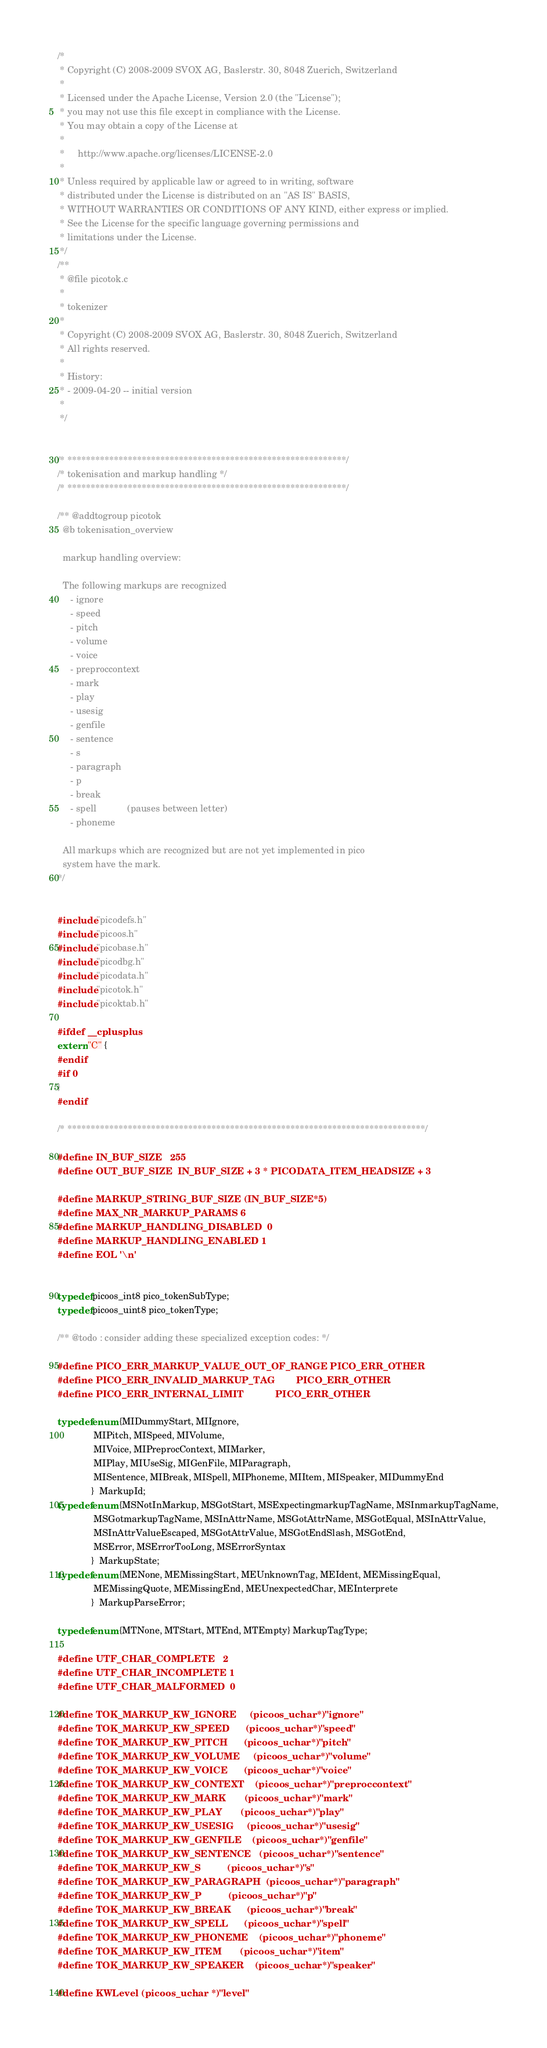<code> <loc_0><loc_0><loc_500><loc_500><_C_>/*
 * Copyright (C) 2008-2009 SVOX AG, Baslerstr. 30, 8048 Zuerich, Switzerland
 *
 * Licensed under the Apache License, Version 2.0 (the "License");
 * you may not use this file except in compliance with the License.
 * You may obtain a copy of the License at
 *
 *     http://www.apache.org/licenses/LICENSE-2.0
 *
 * Unless required by applicable law or agreed to in writing, software
 * distributed under the License is distributed on an "AS IS" BASIS,
 * WITHOUT WARRANTIES OR CONDITIONS OF ANY KIND, either express or implied.
 * See the License for the specific language governing permissions and
 * limitations under the License.
 */
/**
 * @file picotok.c
 *
 * tokenizer
 *
 * Copyright (C) 2008-2009 SVOX AG, Baslerstr. 30, 8048 Zuerich, Switzerland
 * All rights reserved.
 *
 * History:
 * - 2009-04-20 -- initial version
 *
 */


/* ************************************************************/
/* tokenisation and markup handling */
/* ************************************************************/

/** @addtogroup picotok
  @b tokenisation_overview

  markup handling overview:

  The following markups are recognized
     - ignore
     - speed
     - pitch
     - volume
     - voice
     - preproccontext
     - mark
     - play
     - usesig
     - genfile
     - sentence
     - s
     - paragraph
     - p
     - break
     - spell            (pauses between letter)
     - phoneme

  All markups which are recognized but are not yet implemented in pico
  system have the mark.
*/


#include "picodefs.h"
#include "picoos.h"
#include "picobase.h"
#include "picodbg.h"
#include "picodata.h"
#include "picotok.h"
#include "picoktab.h"

#ifdef __cplusplus
extern "C" {
#endif
#if 0
}
#endif

/* *****************************************************************************/

#define IN_BUF_SIZE   255
#define OUT_BUF_SIZE  IN_BUF_SIZE + 3 * PICODATA_ITEM_HEADSIZE + 3

#define MARKUP_STRING_BUF_SIZE (IN_BUF_SIZE*5)
#define MAX_NR_MARKUP_PARAMS 6
#define MARKUP_HANDLING_DISABLED  0
#define MARKUP_HANDLING_ENABLED 1
#define EOL '\n'


typedef picoos_int8 pico_tokenSubType;
typedef picoos_uint8 pico_tokenType;

/** @todo : consider adding these specialized exception codes: */

#define PICO_ERR_MARKUP_VALUE_OUT_OF_RANGE PICO_ERR_OTHER
#define PICO_ERR_INVALID_MARKUP_TAG        PICO_ERR_OTHER
#define PICO_ERR_INTERNAL_LIMIT            PICO_ERR_OTHER

typedef enum {MIDummyStart, MIIgnore,
              MIPitch, MISpeed, MIVolume,
              MIVoice, MIPreprocContext, MIMarker,
              MIPlay, MIUseSig, MIGenFile, MIParagraph,
              MISentence, MIBreak, MISpell, MIPhoneme, MIItem, MISpeaker, MIDummyEnd
             }  MarkupId;
typedef enum {MSNotInMarkup, MSGotStart, MSExpectingmarkupTagName, MSInmarkupTagName,
              MSGotmarkupTagName, MSInAttrName, MSGotAttrName, MSGotEqual, MSInAttrValue,
              MSInAttrValueEscaped, MSGotAttrValue, MSGotEndSlash, MSGotEnd,
              MSError, MSErrorTooLong, MSErrorSyntax
             }  MarkupState;
typedef enum {MENone, MEMissingStart, MEUnknownTag, MEIdent, MEMissingEqual,
              MEMissingQuote, MEMissingEnd, MEUnexpectedChar, MEInterprete
             }  MarkupParseError;

typedef enum {MTNone, MTStart, MTEnd, MTEmpty} MarkupTagType;

#define UTF_CHAR_COMPLETE   2
#define UTF_CHAR_INCOMPLETE 1
#define UTF_CHAR_MALFORMED  0

#define TOK_MARKUP_KW_IGNORE     (picoos_uchar*)"ignore"
#define TOK_MARKUP_KW_SPEED      (picoos_uchar*)"speed"
#define TOK_MARKUP_KW_PITCH      (picoos_uchar*)"pitch"
#define TOK_MARKUP_KW_VOLUME     (picoos_uchar*)"volume"
#define TOK_MARKUP_KW_VOICE      (picoos_uchar*)"voice"
#define TOK_MARKUP_KW_CONTEXT    (picoos_uchar*)"preproccontext"
#define TOK_MARKUP_KW_MARK       (picoos_uchar*)"mark"
#define TOK_MARKUP_KW_PLAY       (picoos_uchar*)"play"
#define TOK_MARKUP_KW_USESIG     (picoos_uchar*)"usesig"
#define TOK_MARKUP_KW_GENFILE    (picoos_uchar*)"genfile"
#define TOK_MARKUP_KW_SENTENCE   (picoos_uchar*)"sentence"
#define TOK_MARKUP_KW_S          (picoos_uchar*)"s"
#define TOK_MARKUP_KW_PARAGRAPH  (picoos_uchar*)"paragraph"
#define TOK_MARKUP_KW_P          (picoos_uchar*)"p"
#define TOK_MARKUP_KW_BREAK      (picoos_uchar*)"break"
#define TOK_MARKUP_KW_SPELL      (picoos_uchar*)"spell"
#define TOK_MARKUP_KW_PHONEME    (picoos_uchar*)"phoneme"
#define TOK_MARKUP_KW_ITEM       (picoos_uchar*)"item"
#define TOK_MARKUP_KW_SPEAKER    (picoos_uchar*)"speaker"

#define KWLevel (picoos_uchar *)"level"</code> 